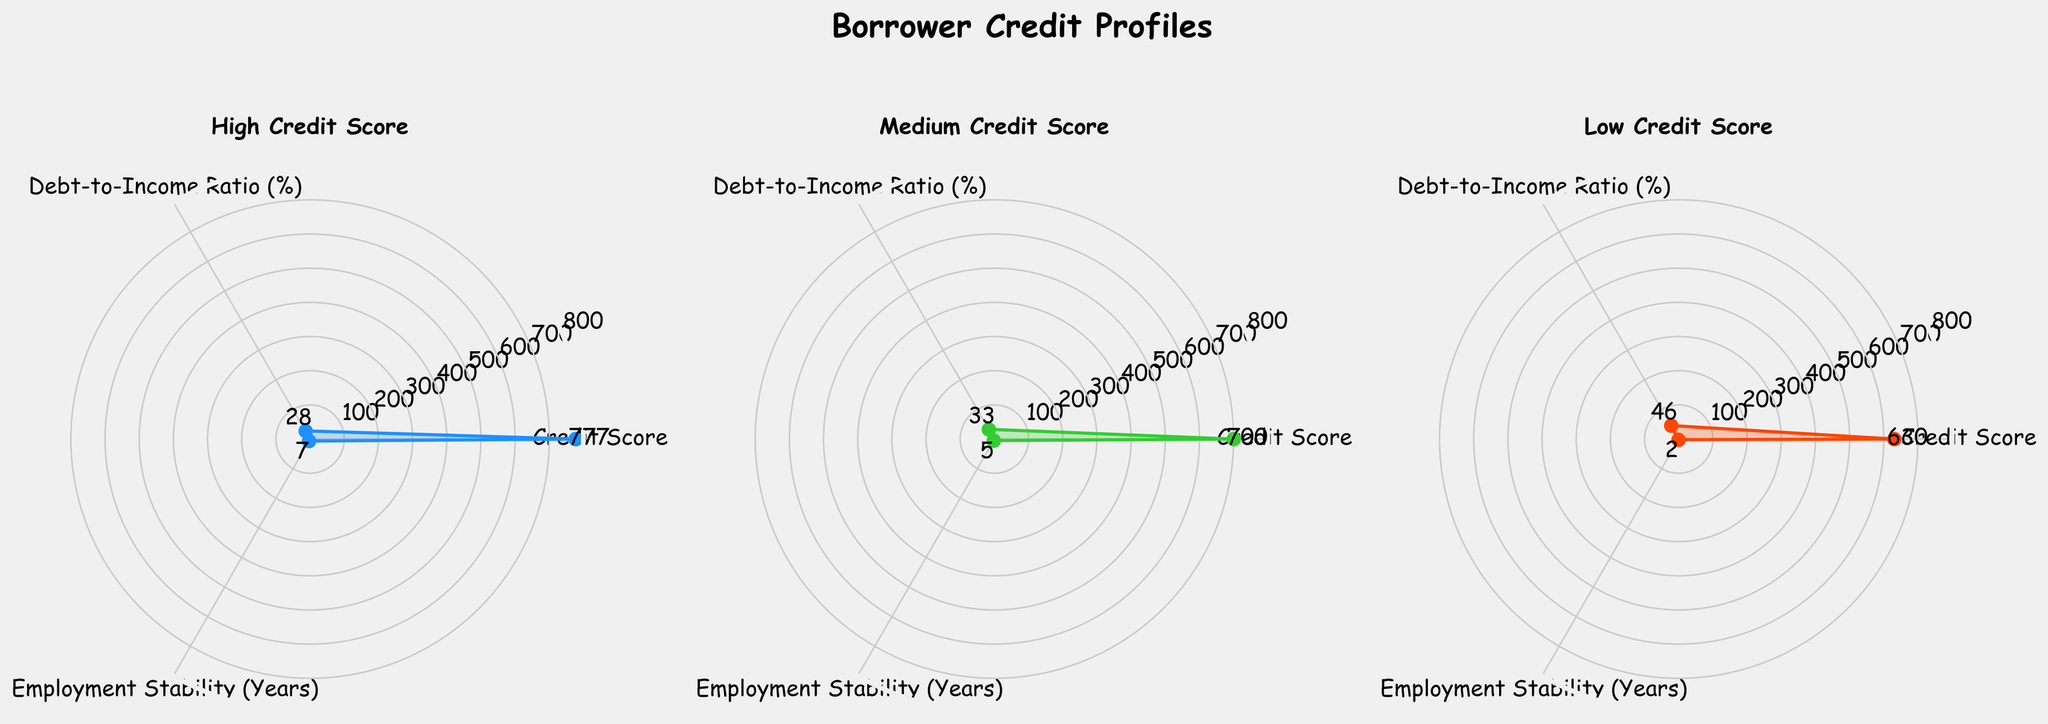How many subplots are there in the figure? There is a total of three subplots, one for each credit category (High Credit Score, Medium Credit Score, Low Credit Score)
Answer: Three What is the average Credit Score for the High Credit Score group? The radar chart shows the average Credit Score at the vertex for each category. For the High Credit Score group, the value is approximately 777
Answer: 777 Which credit category has the highest Debt-to-Income Ratio (%)? By comparing the values at the Debt-to-Income Ratio (%) axis, we can see that the Low Credit Score category has the highest value, with an average of about 45%
Answer: Low Credit Score Which category shows the least Employment Stability (Years)? The radar chart indicates that the Low Credit Score group has the least Employment Stability, with an average close to 2 years
Answer: Low Credit Score What is the approximate value gap between the High and Low Credit Score groups in Credit Score? The High Credit Score group has an average score of 777, while the Low Credit Score group has an average score of about 630. The difference is 777 - 630 = 147
Answer: 147 Which category has the most stable employment years on average? According to the radar chart, the High Credit Score group has the highest Employment Stability with an average around 6.7 years
Answer: High Credit Score How do the Debt-to-Income Ratios compare between the Medium and Low Credit Score groups? The Medium Credit Score group has an average Debt-to-Income Ratio of about 33%, while the Low Credit Score group's average is approximately 45%. 45% is higher than 33%
Answer: Low Credit Score group has higher Debt-to-Income Ratio What is the average Debt-to-Income Ratio (%) across all three categories? Average the Debt-to-Income Ratio across the three categories: (28 + 35 + 45) / 3 = 36%
Answer: 36% Which category appears to be more evenly distributed across the three metrics? The radar chart shows the High Credit Score group's plot as more evenly spread out compared to the other groups, implying balanced Credit Score, Debt-to-Income Ratio, and Employment Stability
Answer: High Credit Score What can you infer about the relationship between Credit Score and Employment Stability from the data? The radar chart indicates that higher Credit Scores are associated with greater Employment Stability. The High Credit Score group has both high Credit Scores and more stable employment
Answer: Higher Credit Score is linked to greater Employment Stability 